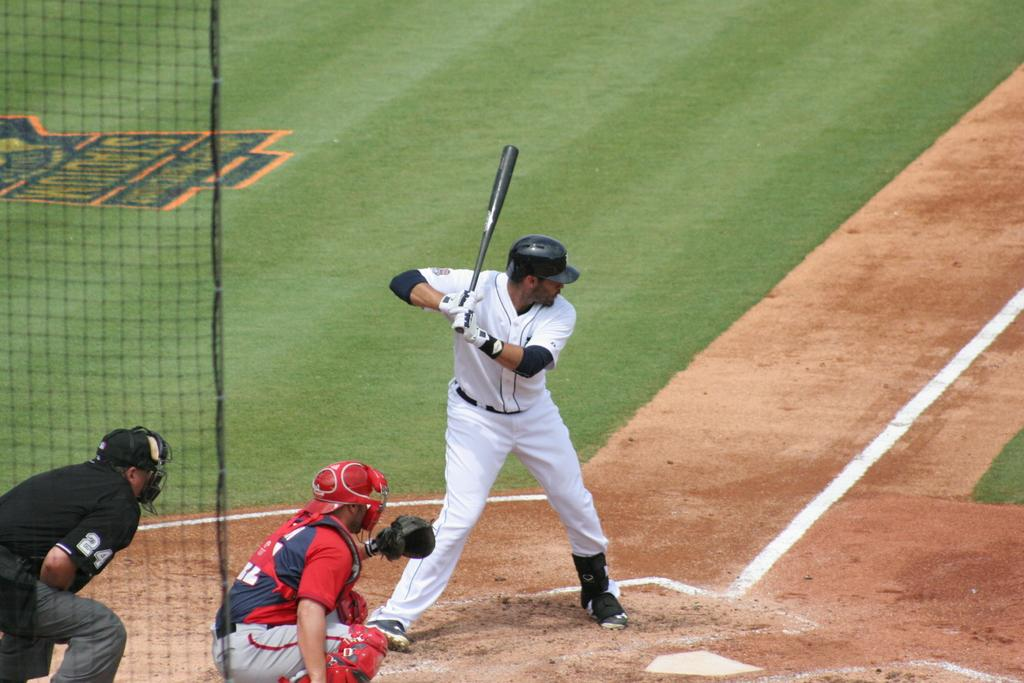Provide a one-sentence caption for the provided image. a batter in front of an Umpire with the number 24. 